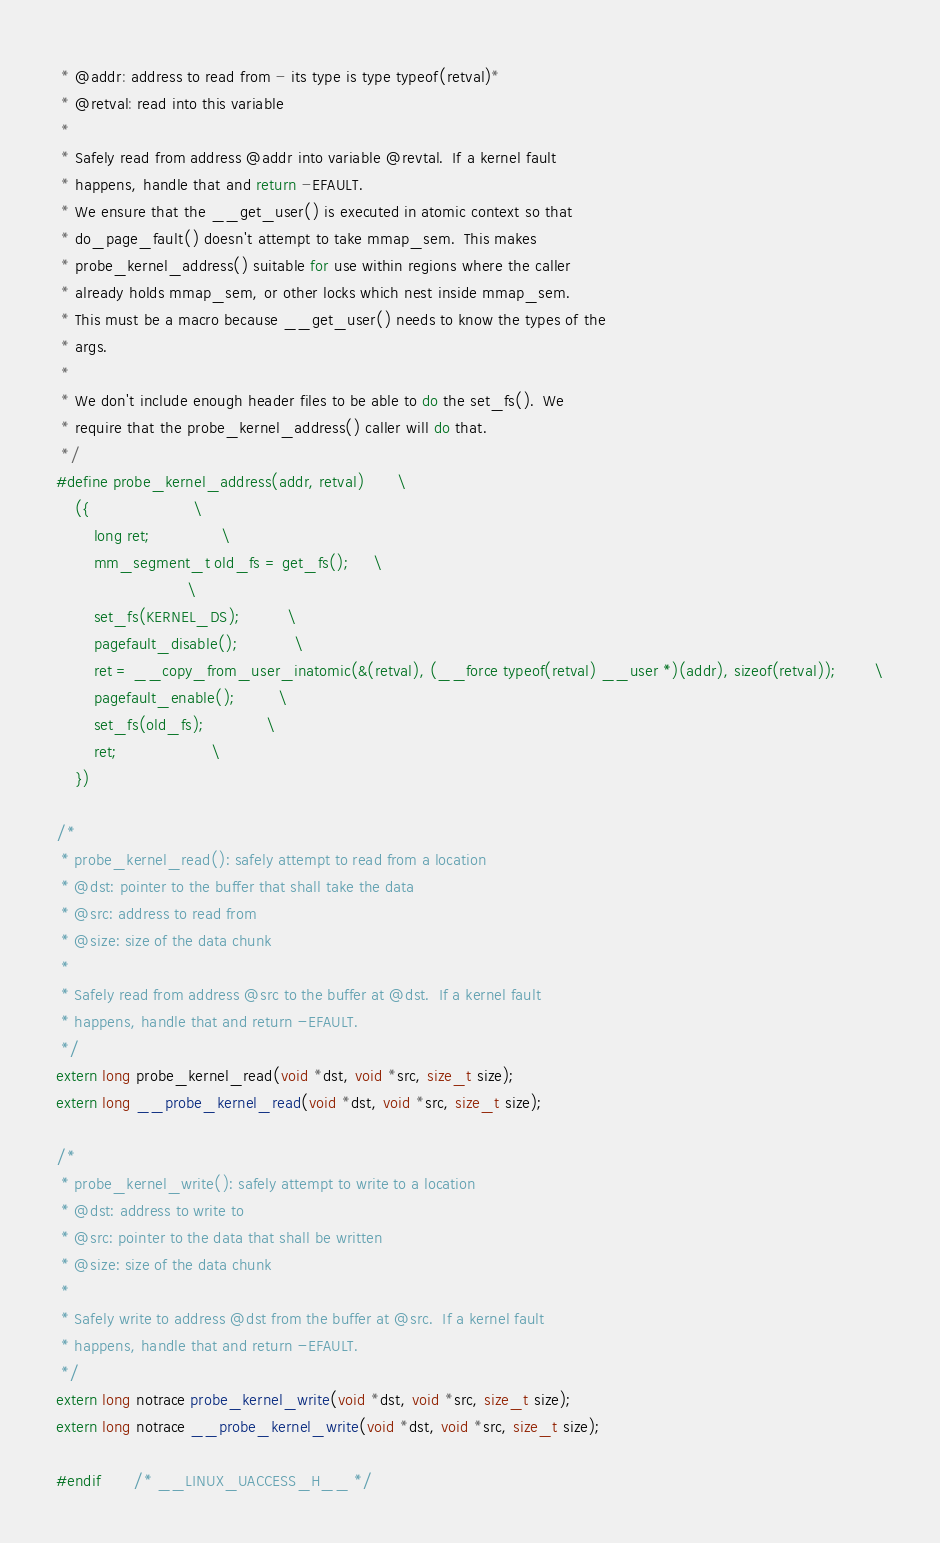Convert code to text. <code><loc_0><loc_0><loc_500><loc_500><_C_> * @addr: address to read from - its type is type typeof(retval)*
 * @retval: read into this variable
 *
 * Safely read from address @addr into variable @revtal.  If a kernel fault
 * happens, handle that and return -EFAULT.
 * We ensure that the __get_user() is executed in atomic context so that
 * do_page_fault() doesn't attempt to take mmap_sem.  This makes
 * probe_kernel_address() suitable for use within regions where the caller
 * already holds mmap_sem, or other locks which nest inside mmap_sem.
 * This must be a macro because __get_user() needs to know the types of the
 * args.
 *
 * We don't include enough header files to be able to do the set_fs().  We
 * require that the probe_kernel_address() caller will do that.
 */
#define probe_kernel_address(addr, retval)		\
	({						\
		long ret;				\
		mm_segment_t old_fs = get_fs();		\
							\
		set_fs(KERNEL_DS);			\
		pagefault_disable();			\
		ret = __copy_from_user_inatomic(&(retval), (__force typeof(retval) __user *)(addr), sizeof(retval));		\
		pagefault_enable();			\
		set_fs(old_fs);				\
		ret;					\
	})

/*
 * probe_kernel_read(): safely attempt to read from a location
 * @dst: pointer to the buffer that shall take the data
 * @src: address to read from
 * @size: size of the data chunk
 *
 * Safely read from address @src to the buffer at @dst.  If a kernel fault
 * happens, handle that and return -EFAULT.
 */
extern long probe_kernel_read(void *dst, void *src, size_t size);
extern long __probe_kernel_read(void *dst, void *src, size_t size);

/*
 * probe_kernel_write(): safely attempt to write to a location
 * @dst: address to write to
 * @src: pointer to the data that shall be written
 * @size: size of the data chunk
 *
 * Safely write to address @dst from the buffer at @src.  If a kernel fault
 * happens, handle that and return -EFAULT.
 */
extern long notrace probe_kernel_write(void *dst, void *src, size_t size);
extern long notrace __probe_kernel_write(void *dst, void *src, size_t size);

#endif		/* __LINUX_UACCESS_H__ */
</code> 